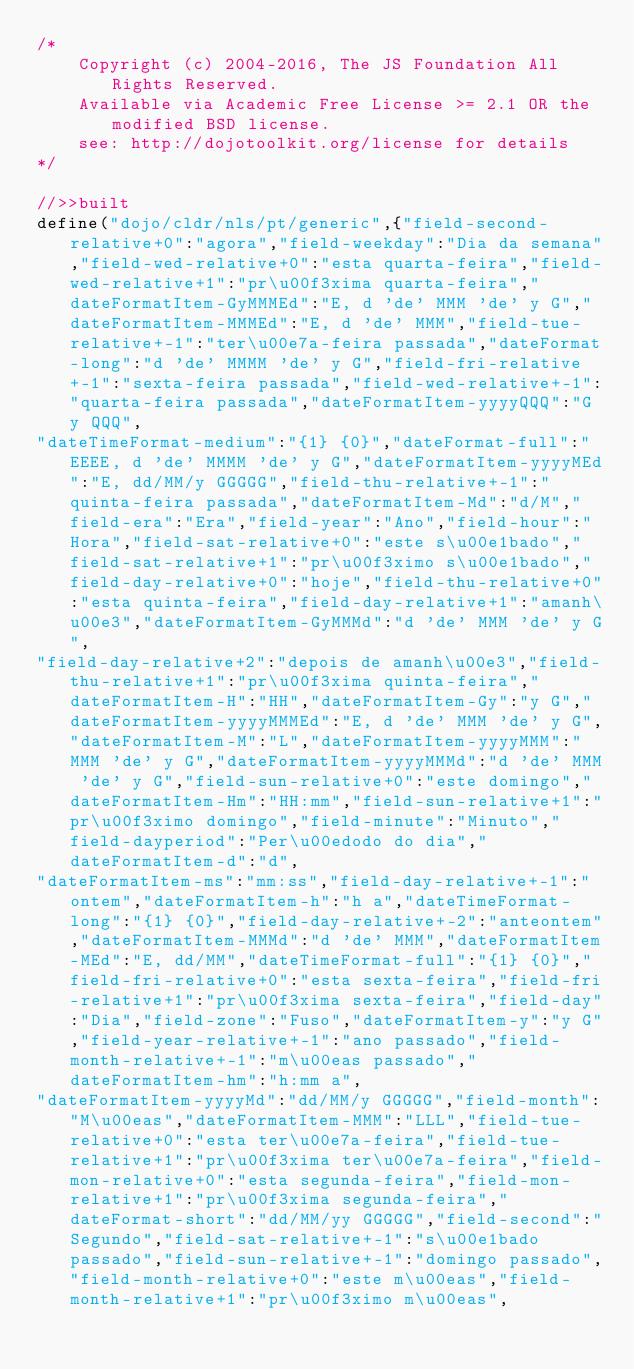Convert code to text. <code><loc_0><loc_0><loc_500><loc_500><_JavaScript_>/*
	Copyright (c) 2004-2016, The JS Foundation All Rights Reserved.
	Available via Academic Free License >= 2.1 OR the modified BSD license.
	see: http://dojotoolkit.org/license for details
*/

//>>built
define("dojo/cldr/nls/pt/generic",{"field-second-relative+0":"agora","field-weekday":"Dia da semana","field-wed-relative+0":"esta quarta-feira","field-wed-relative+1":"pr\u00f3xima quarta-feira","dateFormatItem-GyMMMEd":"E, d 'de' MMM 'de' y G","dateFormatItem-MMMEd":"E, d 'de' MMM","field-tue-relative+-1":"ter\u00e7a-feira passada","dateFormat-long":"d 'de' MMMM 'de' y G","field-fri-relative+-1":"sexta-feira passada","field-wed-relative+-1":"quarta-feira passada","dateFormatItem-yyyyQQQ":"G y QQQ",
"dateTimeFormat-medium":"{1} {0}","dateFormat-full":"EEEE, d 'de' MMMM 'de' y G","dateFormatItem-yyyyMEd":"E, dd/MM/y GGGGG","field-thu-relative+-1":"quinta-feira passada","dateFormatItem-Md":"d/M","field-era":"Era","field-year":"Ano","field-hour":"Hora","field-sat-relative+0":"este s\u00e1bado","field-sat-relative+1":"pr\u00f3ximo s\u00e1bado","field-day-relative+0":"hoje","field-thu-relative+0":"esta quinta-feira","field-day-relative+1":"amanh\u00e3","dateFormatItem-GyMMMd":"d 'de' MMM 'de' y G",
"field-day-relative+2":"depois de amanh\u00e3","field-thu-relative+1":"pr\u00f3xima quinta-feira","dateFormatItem-H":"HH","dateFormatItem-Gy":"y G","dateFormatItem-yyyyMMMEd":"E, d 'de' MMM 'de' y G","dateFormatItem-M":"L","dateFormatItem-yyyyMMM":"MMM 'de' y G","dateFormatItem-yyyyMMMd":"d 'de' MMM 'de' y G","field-sun-relative+0":"este domingo","dateFormatItem-Hm":"HH:mm","field-sun-relative+1":"pr\u00f3ximo domingo","field-minute":"Minuto","field-dayperiod":"Per\u00edodo do dia","dateFormatItem-d":"d",
"dateFormatItem-ms":"mm:ss","field-day-relative+-1":"ontem","dateFormatItem-h":"h a","dateTimeFormat-long":"{1} {0}","field-day-relative+-2":"anteontem","dateFormatItem-MMMd":"d 'de' MMM","dateFormatItem-MEd":"E, dd/MM","dateTimeFormat-full":"{1} {0}","field-fri-relative+0":"esta sexta-feira","field-fri-relative+1":"pr\u00f3xima sexta-feira","field-day":"Dia","field-zone":"Fuso","dateFormatItem-y":"y G","field-year-relative+-1":"ano passado","field-month-relative+-1":"m\u00eas passado","dateFormatItem-hm":"h:mm a",
"dateFormatItem-yyyyMd":"dd/MM/y GGGGG","field-month":"M\u00eas","dateFormatItem-MMM":"LLL","field-tue-relative+0":"esta ter\u00e7a-feira","field-tue-relative+1":"pr\u00f3xima ter\u00e7a-feira","field-mon-relative+0":"esta segunda-feira","field-mon-relative+1":"pr\u00f3xima segunda-feira","dateFormat-short":"dd/MM/yy GGGGG","field-second":"Segundo","field-sat-relative+-1":"s\u00e1bado passado","field-sun-relative+-1":"domingo passado","field-month-relative+0":"este m\u00eas","field-month-relative+1":"pr\u00f3ximo m\u00eas",</code> 